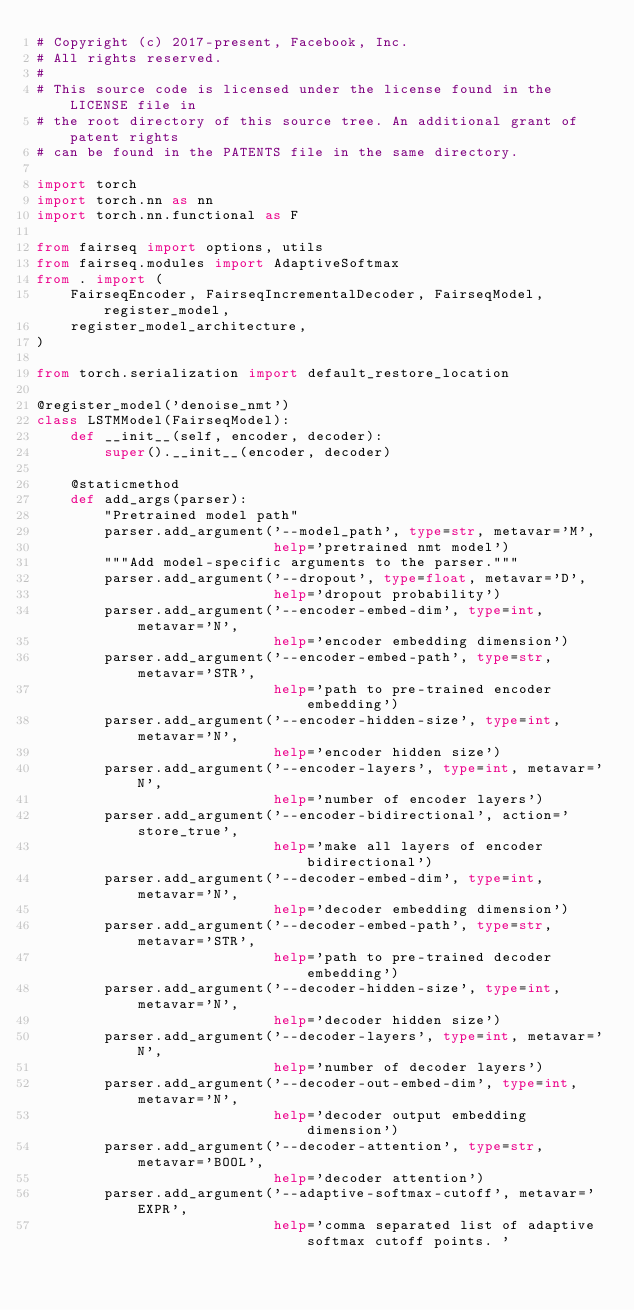<code> <loc_0><loc_0><loc_500><loc_500><_Python_># Copyright (c) 2017-present, Facebook, Inc.
# All rights reserved.
#
# This source code is licensed under the license found in the LICENSE file in
# the root directory of this source tree. An additional grant of patent rights
# can be found in the PATENTS file in the same directory.

import torch
import torch.nn as nn
import torch.nn.functional as F

from fairseq import options, utils
from fairseq.modules import AdaptiveSoftmax
from . import (
    FairseqEncoder, FairseqIncrementalDecoder, FairseqModel, register_model,
    register_model_architecture,
)

from torch.serialization import default_restore_location

@register_model('denoise_nmt')
class LSTMModel(FairseqModel):
    def __init__(self, encoder, decoder):
        super().__init__(encoder, decoder)

    @staticmethod
    def add_args(parser):
        "Pretrained model path"
        parser.add_argument('--model_path', type=str, metavar='M',
                            help='pretrained nmt model')
        """Add model-specific arguments to the parser."""
        parser.add_argument('--dropout', type=float, metavar='D',
                            help='dropout probability')
        parser.add_argument('--encoder-embed-dim', type=int, metavar='N',
                            help='encoder embedding dimension')
        parser.add_argument('--encoder-embed-path', type=str, metavar='STR',
                            help='path to pre-trained encoder embedding')
        parser.add_argument('--encoder-hidden-size', type=int, metavar='N',
                            help='encoder hidden size')
        parser.add_argument('--encoder-layers', type=int, metavar='N',
                            help='number of encoder layers')
        parser.add_argument('--encoder-bidirectional', action='store_true',
                            help='make all layers of encoder bidirectional')
        parser.add_argument('--decoder-embed-dim', type=int, metavar='N',
                            help='decoder embedding dimension')
        parser.add_argument('--decoder-embed-path', type=str, metavar='STR',
                            help='path to pre-trained decoder embedding')
        parser.add_argument('--decoder-hidden-size', type=int, metavar='N',
                            help='decoder hidden size')
        parser.add_argument('--decoder-layers', type=int, metavar='N',
                            help='number of decoder layers')
        parser.add_argument('--decoder-out-embed-dim', type=int, metavar='N',
                            help='decoder output embedding dimension')
        parser.add_argument('--decoder-attention', type=str, metavar='BOOL',
                            help='decoder attention')
        parser.add_argument('--adaptive-softmax-cutoff', metavar='EXPR',
                            help='comma separated list of adaptive softmax cutoff points. '</code> 